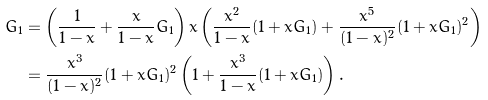<formula> <loc_0><loc_0><loc_500><loc_500>G _ { 1 } & = \left ( \frac { 1 } { 1 - x } + \frac { x } { 1 - x } G _ { 1 } \right ) x \left ( \frac { x ^ { 2 } } { 1 - x } ( 1 + x G _ { 1 } ) + \frac { x ^ { 5 } } { ( 1 - x ) ^ { 2 } } ( 1 + x G _ { 1 } ) ^ { 2 } \right ) \\ & = \frac { x ^ { 3 } } { ( 1 - x ) ^ { 2 } } ( 1 + x G _ { 1 } ) ^ { 2 } \left ( 1 + \frac { x ^ { 3 } } { 1 - x } ( 1 + x G _ { 1 } ) \right ) .</formula> 